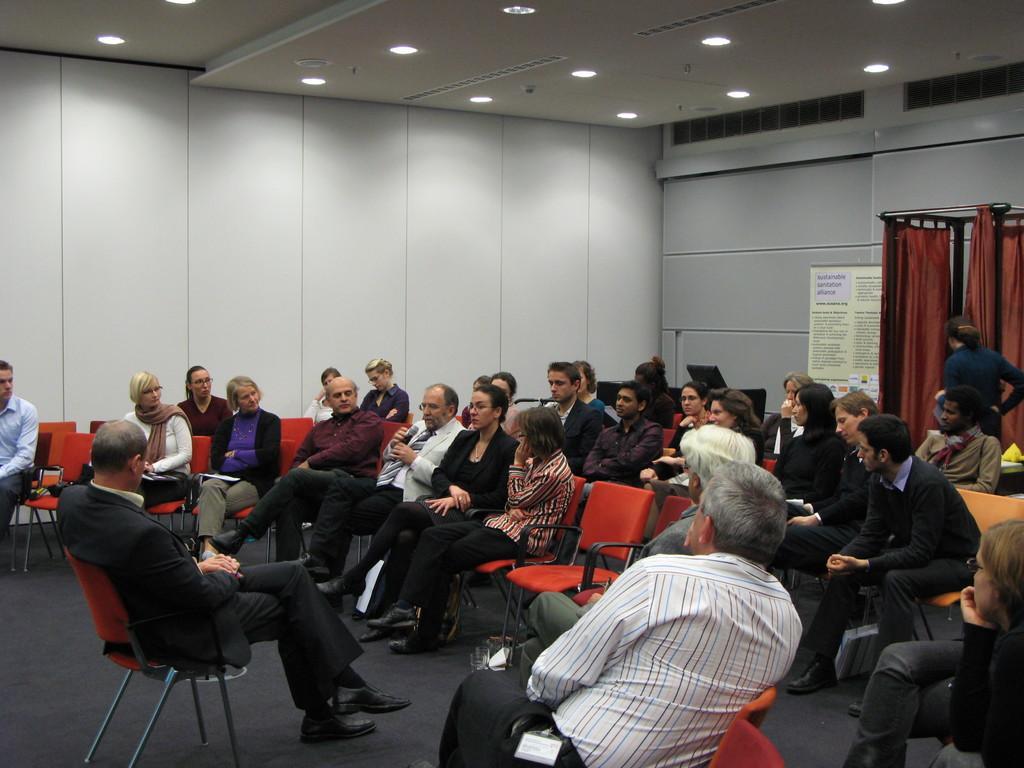Can you describe this image briefly? There is crowd of people sitting on chairs. There is a old man in the middle wearing a white suit with mic talking. All are sitting in a room. The ceiling has several lights on it and it has AC vents on right side of the wall. There is stand with cloth on the backside. 